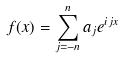<formula> <loc_0><loc_0><loc_500><loc_500>f ( x ) = \sum _ { j = - n } ^ { n } a _ { j } e ^ { i j x }</formula> 